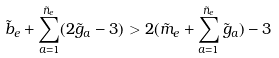<formula> <loc_0><loc_0><loc_500><loc_500>\tilde { b } _ { e } + \sum ^ { \tilde { n } _ { e } } _ { a = 1 } ( 2 \tilde { g } _ { a } - 3 ) > 2 ( \tilde { m } _ { e } + \sum ^ { \tilde { n } _ { e } } _ { a = 1 } \tilde { g } _ { a } ) - 3</formula> 